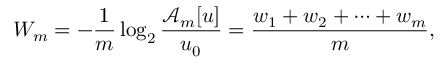Convert formula to latex. <formula><loc_0><loc_0><loc_500><loc_500>W _ { m } = - \frac { 1 } { m } \log _ { 2 } \frac { \mathcal { A } _ { m } [ u ] } { u _ { 0 } } = \frac { w _ { 1 } + w _ { 2 } + \cdots + w _ { m } } { m } ,</formula> 